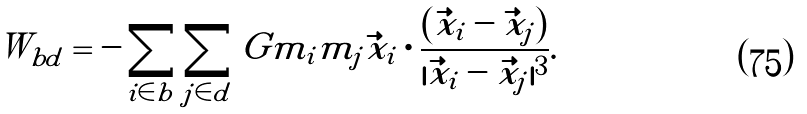<formula> <loc_0><loc_0><loc_500><loc_500>W _ { b d } = - \sum _ { i \in b } \sum _ { j \in d } G m _ { i } m _ { j } \vec { x } _ { i } \cdot \frac { ( \vec { x } _ { i } - \vec { x } _ { j } ) } { | \vec { x } _ { i } - \vec { x _ { j } } | ^ { 3 } } .</formula> 